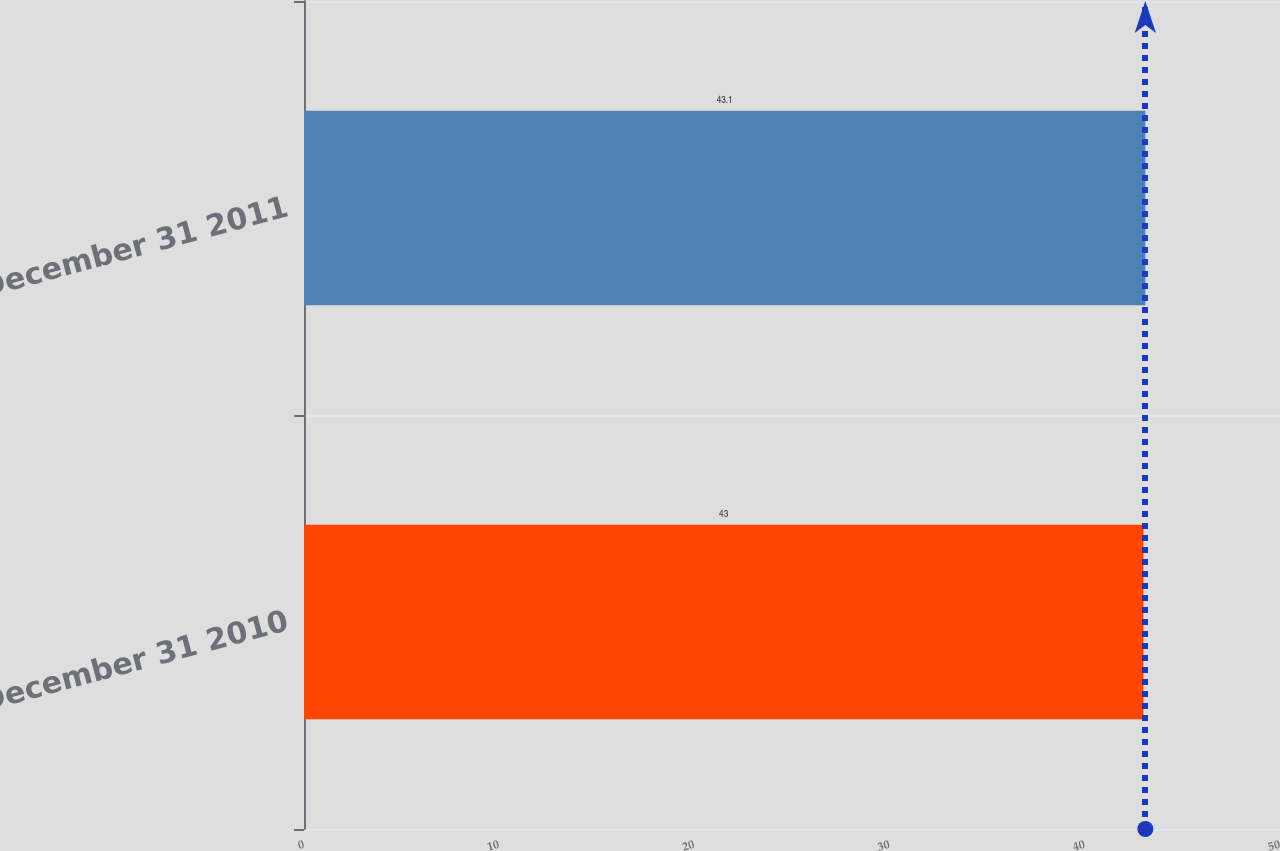Convert chart. <chart><loc_0><loc_0><loc_500><loc_500><bar_chart><fcel>December 31 2010<fcel>December 31 2011<nl><fcel>43<fcel>43.1<nl></chart> 